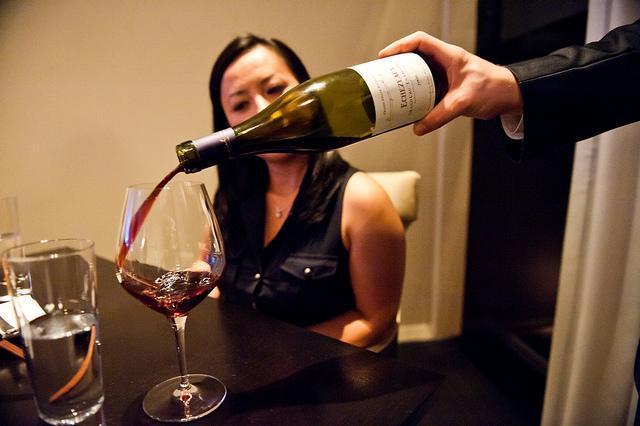How many glasses of water are in the picture?
Give a very brief answer. 1. How many people are in the picture?
Give a very brief answer. 2. 